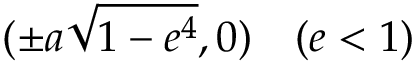<formula> <loc_0><loc_0><loc_500><loc_500>( \pm a { \sqrt { 1 - e ^ { 4 } } } , 0 ) \quad ( e < 1 )</formula> 